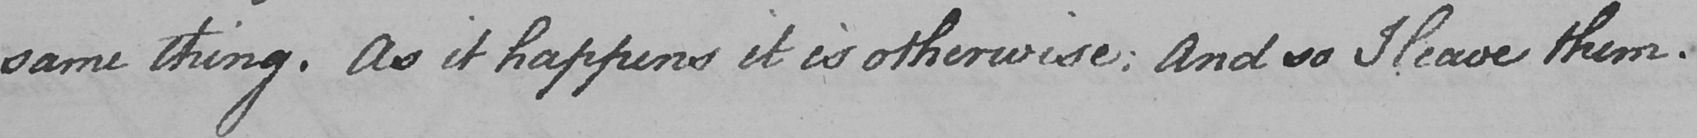Please transcribe the handwritten text in this image. same thing . As it happens it is otherwise :  And so I leave them . 